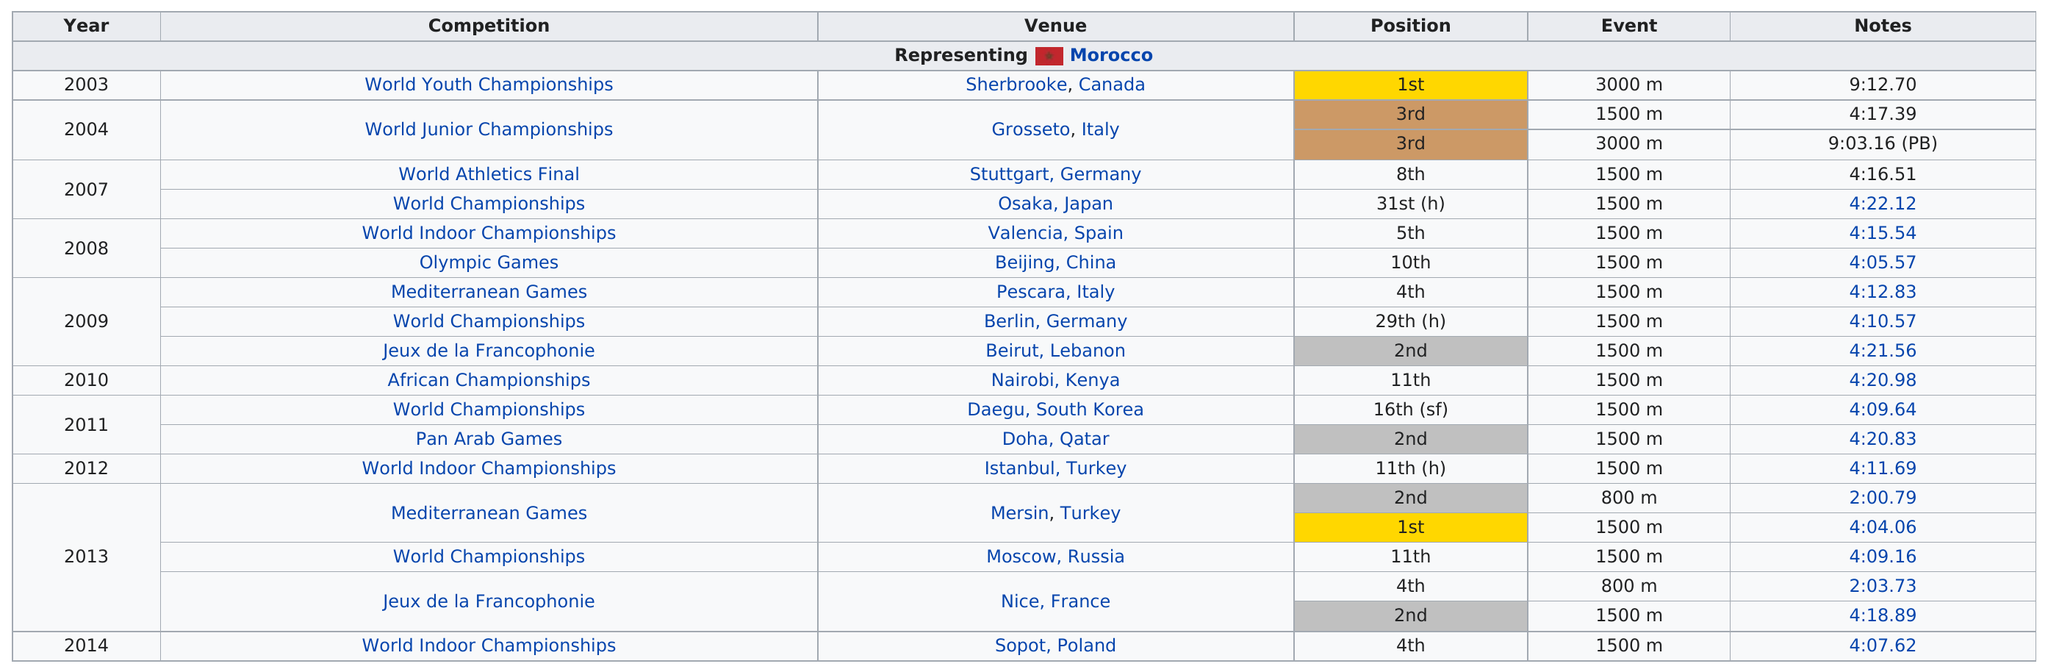Highlight a few significant elements in this photo. There are two 800 meter events. In 2011, in addition to the Pan Arab Games, she completed other competitions that same year, including the World Championships. She ran a total of 11 races after the 2008 Olympics. In the year 2003, the first time she placed first, she achieved this feat. In 2010, she was the only year in which she competed in Kenya. 